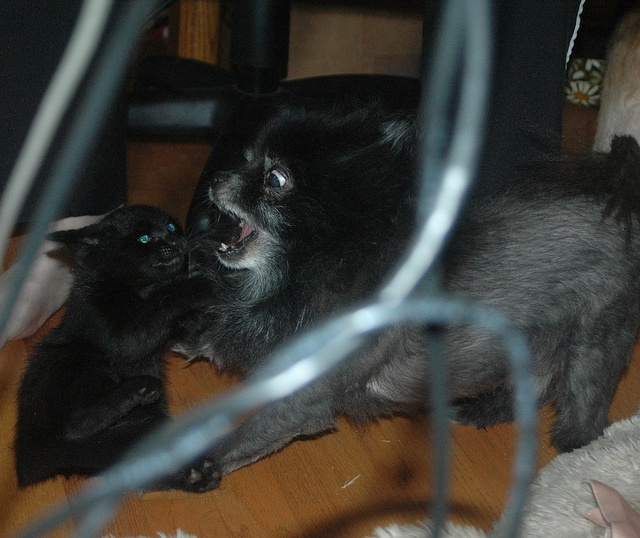Describe the objects in this image and their specific colors. I can see dog in black and gray tones and cat in black, gray, and maroon tones in this image. 